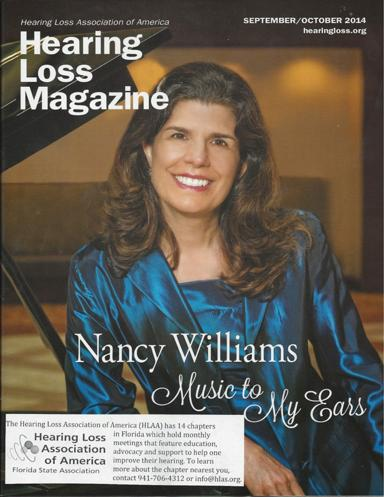Who is Nancy Williams and what is her connection to the magazine? Nancy Williams, prominently featured on the cover of the 'Hearing Loss Magazine,' is an advocate and possibly a contributor to the magazine. She shares her experiences and insights as a music enthusiast with a hearing loss, aiming to inspire and educate others. 